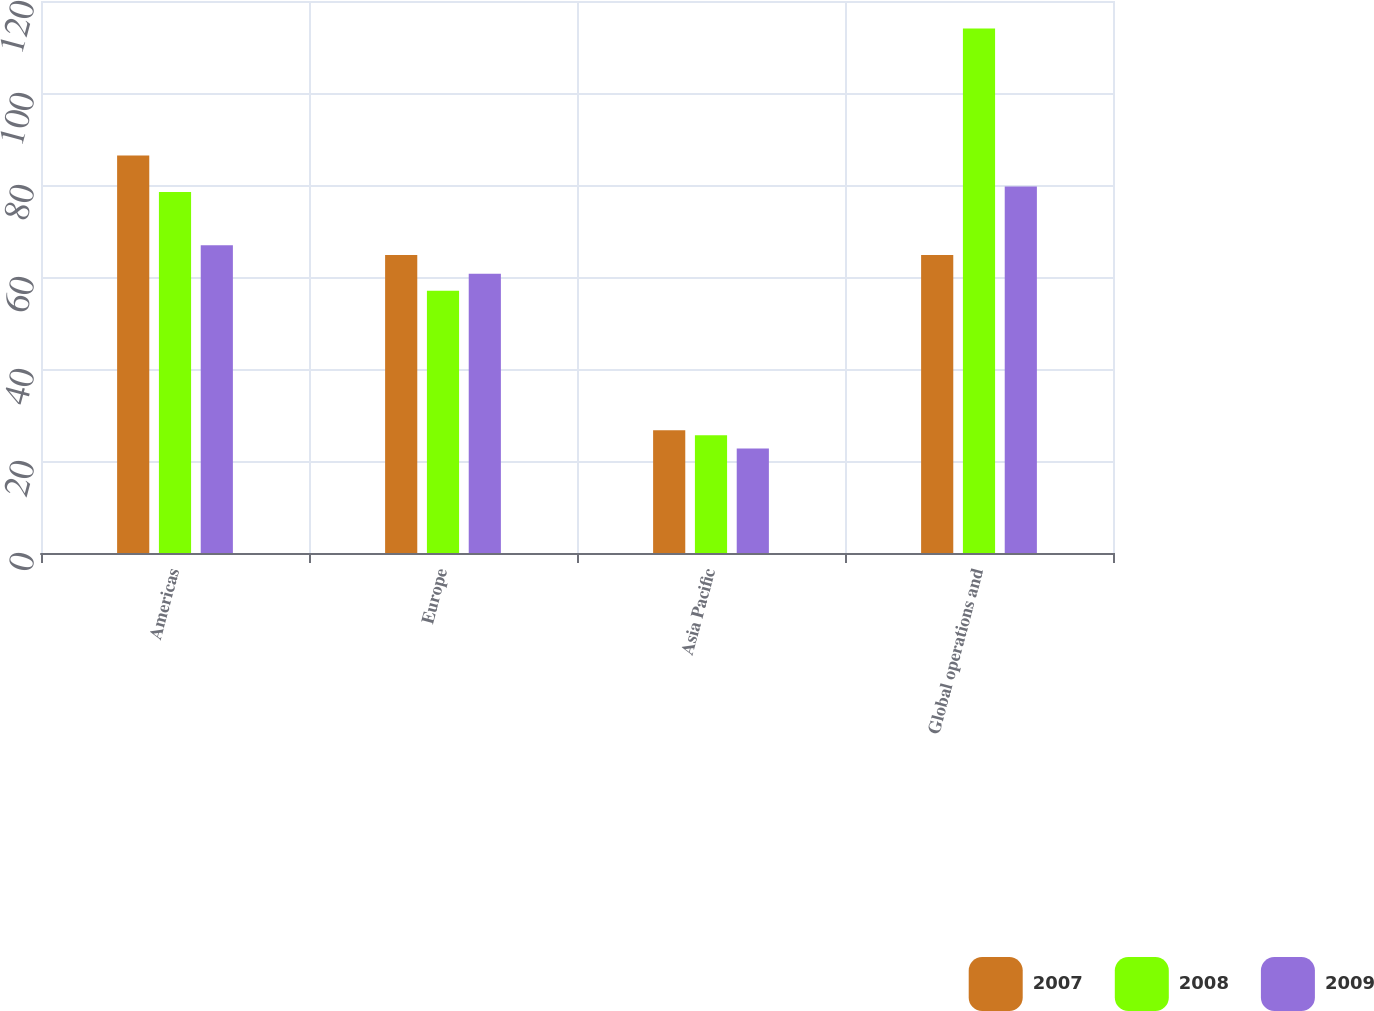Convert chart. <chart><loc_0><loc_0><loc_500><loc_500><stacked_bar_chart><ecel><fcel>Americas<fcel>Europe<fcel>Asia Pacific<fcel>Global operations and<nl><fcel>2007<fcel>86.4<fcel>64.8<fcel>26.7<fcel>64.8<nl><fcel>2008<fcel>78.5<fcel>57<fcel>25.6<fcel>114<nl><fcel>2009<fcel>66.9<fcel>60.7<fcel>22.7<fcel>79.7<nl></chart> 